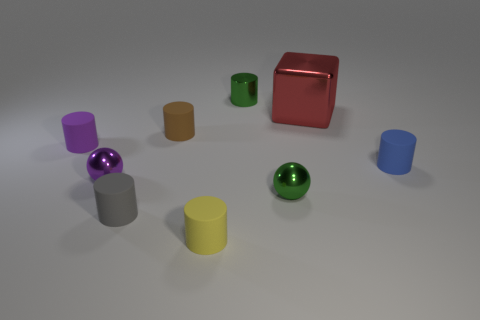Subtract all tiny brown rubber cylinders. How many cylinders are left? 5 Subtract all brown cylinders. How many cylinders are left? 5 Add 1 tiny blue rubber cylinders. How many objects exist? 10 Subtract all balls. How many objects are left? 7 Subtract 2 balls. How many balls are left? 0 Subtract all cyan metal balls. Subtract all big cubes. How many objects are left? 8 Add 3 small yellow cylinders. How many small yellow cylinders are left? 4 Add 3 purple rubber things. How many purple rubber things exist? 4 Subtract 0 brown balls. How many objects are left? 9 Subtract all gray cylinders. Subtract all purple spheres. How many cylinders are left? 5 